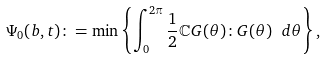Convert formula to latex. <formula><loc_0><loc_0><loc_500><loc_500>\Psi _ { 0 } ( b , t ) \colon = \min \left \{ \int _ { 0 } ^ { 2 \pi } \frac { 1 } { 2 } \mathbb { C } G ( \theta ) \colon G ( \theta ) \ d \theta \right \} ,</formula> 